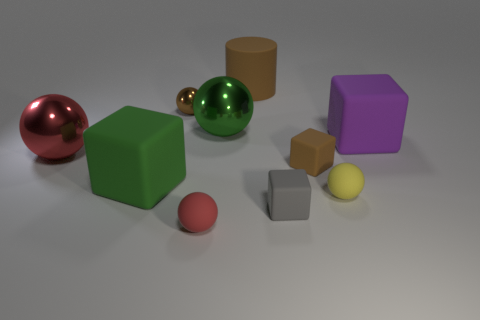The small metallic object that is the same color as the rubber cylinder is what shape?
Ensure brevity in your answer.  Sphere. Do the green matte block and the yellow matte ball have the same size?
Give a very brief answer. No. Is the number of big things that are in front of the large green metallic ball the same as the number of small gray cubes behind the brown shiny thing?
Keep it short and to the point. No. The big purple object that is right of the green metal object has what shape?
Your response must be concise. Cube. The brown matte object that is the same size as the green rubber block is what shape?
Keep it short and to the point. Cylinder. There is a tiny block in front of the big object in front of the metallic ball that is in front of the purple thing; what is its color?
Offer a terse response. Gray. Is the green matte object the same shape as the tiny red thing?
Your answer should be very brief. No. Are there an equal number of brown matte cylinders right of the brown cylinder and large gray things?
Your response must be concise. Yes. How many other objects are the same material as the small yellow ball?
Make the answer very short. 6. There is a green thing on the left side of the brown sphere; is it the same size as the red object that is in front of the tiny yellow rubber object?
Make the answer very short. No. 